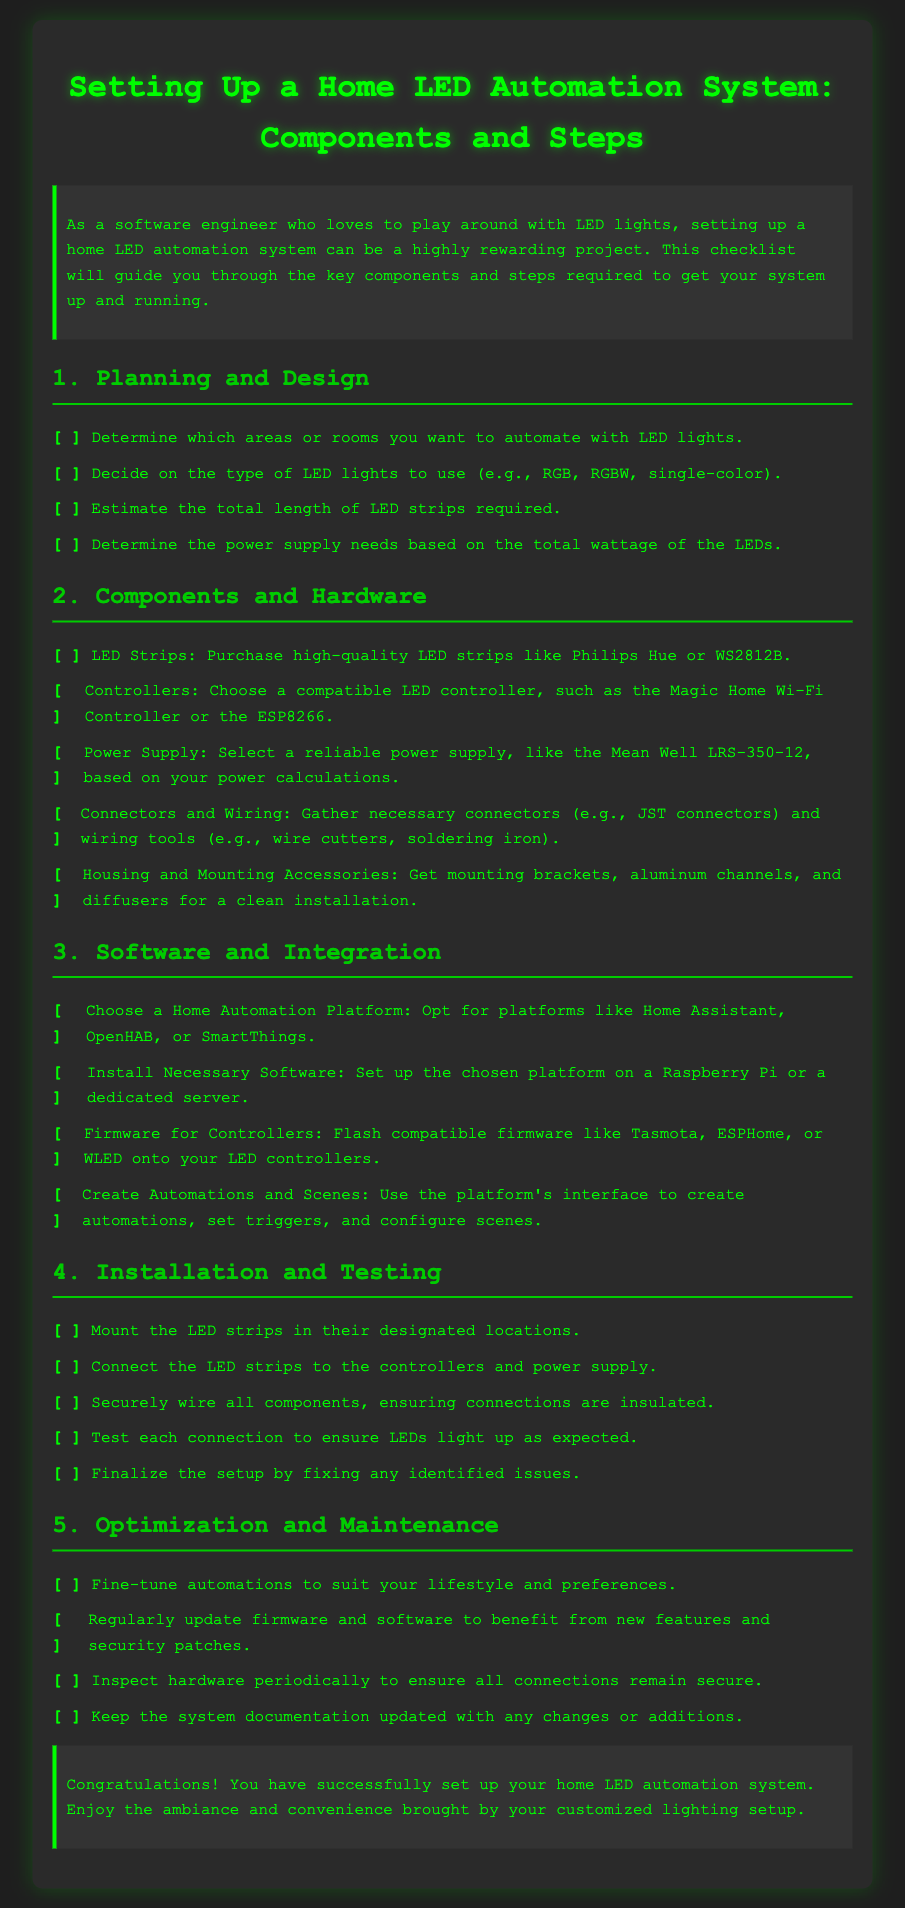what type of LED lights can be used? The document lists RGB, RGBW, and single-color as types of LED lights that can be used.
Answer: RGB, RGBW, single-color which platforms can be chosen for home automation? The document mentions Home Assistant, OpenHAB, and SmartThings as platforms for home automation.
Answer: Home Assistant, OpenHAB, SmartThings how many steps are there in total? The document outlines five main steps for setting up a home LED automation system.
Answer: 5 what are the mounting accessories needed? The document states that mounting brackets, aluminum channels, and diffusers are required for a clean installation.
Answer: mounting brackets, aluminum channels, diffusers what firmware can be flashed onto LED controllers? Compatible firmware options mentioned include Tasmota, ESPHome, or WLED.
Answer: Tasmota, ESPHome, WLED which power supply is recommended? The document suggests using the Mean Well LRS-350-12 as a reliable power supply.
Answer: Mean Well LRS-350-12 what is the first step in the process? The first step involves planning and designing the LED automation setup.
Answer: Planning and Design what is one task involved in the installation step? One task is to connect the LED strips to the controllers and power supply during the installation step.
Answer: Connect the LED strips to the controllers and power supply what should be done regularly for maintenance? The document suggests regularly updating firmware and software for maintenance.
Answer: Regularly update firmware and software 